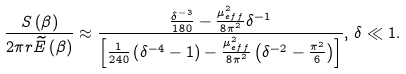<formula> <loc_0><loc_0><loc_500><loc_500>\frac { S \left ( \beta \right ) } { 2 \pi r \widetilde { E } \left ( \beta \right ) } \approx \frac { \frac { \delta ^ { - 3 } } { 1 8 0 } - \frac { \mu _ { e f f } ^ { 2 } } { 8 \pi ^ { 2 } } \delta ^ { - 1 } } { \left [ \frac { 1 } { 2 4 0 } \left ( \delta ^ { - 4 } - 1 \right ) - \frac { \mu _ { e f f } ^ { 2 } } { 8 \pi ^ { 2 } } \left ( \delta ^ { - 2 } - \frac { \pi ^ { 2 } } { 6 } \right ) \right ] } , \, \delta \ll 1 .</formula> 